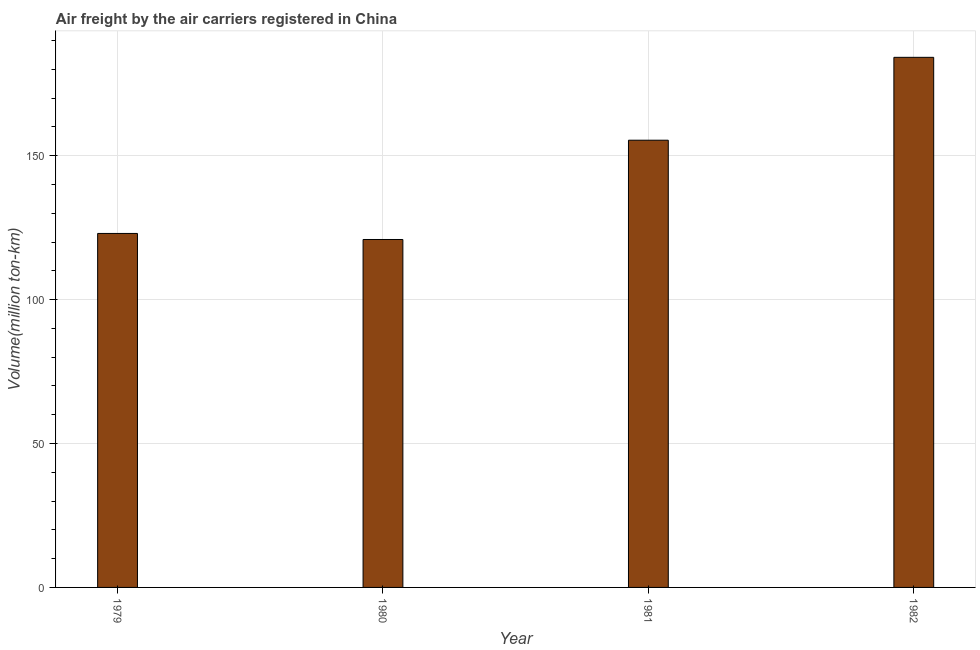Does the graph contain any zero values?
Offer a very short reply. No. Does the graph contain grids?
Make the answer very short. Yes. What is the title of the graph?
Your answer should be very brief. Air freight by the air carriers registered in China. What is the label or title of the Y-axis?
Provide a short and direct response. Volume(million ton-km). What is the air freight in 1980?
Provide a short and direct response. 120.9. Across all years, what is the maximum air freight?
Keep it short and to the point. 184.2. Across all years, what is the minimum air freight?
Offer a terse response. 120.9. What is the sum of the air freight?
Offer a terse response. 583.5. What is the difference between the air freight in 1981 and 1982?
Make the answer very short. -28.8. What is the average air freight per year?
Your answer should be compact. 145.88. What is the median air freight?
Offer a terse response. 139.2. What is the ratio of the air freight in 1980 to that in 1982?
Give a very brief answer. 0.66. Is the difference between the air freight in 1979 and 1982 greater than the difference between any two years?
Your answer should be very brief. No. What is the difference between the highest and the second highest air freight?
Your answer should be compact. 28.8. Is the sum of the air freight in 1980 and 1981 greater than the maximum air freight across all years?
Provide a succinct answer. Yes. What is the difference between the highest and the lowest air freight?
Your answer should be very brief. 63.3. In how many years, is the air freight greater than the average air freight taken over all years?
Your answer should be compact. 2. Are all the bars in the graph horizontal?
Keep it short and to the point. No. What is the difference between two consecutive major ticks on the Y-axis?
Your answer should be compact. 50. Are the values on the major ticks of Y-axis written in scientific E-notation?
Provide a short and direct response. No. What is the Volume(million ton-km) of 1979?
Offer a terse response. 123. What is the Volume(million ton-km) of 1980?
Keep it short and to the point. 120.9. What is the Volume(million ton-km) in 1981?
Keep it short and to the point. 155.4. What is the Volume(million ton-km) of 1982?
Ensure brevity in your answer.  184.2. What is the difference between the Volume(million ton-km) in 1979 and 1981?
Provide a short and direct response. -32.4. What is the difference between the Volume(million ton-km) in 1979 and 1982?
Provide a succinct answer. -61.2. What is the difference between the Volume(million ton-km) in 1980 and 1981?
Make the answer very short. -34.5. What is the difference between the Volume(million ton-km) in 1980 and 1982?
Your answer should be compact. -63.3. What is the difference between the Volume(million ton-km) in 1981 and 1982?
Ensure brevity in your answer.  -28.8. What is the ratio of the Volume(million ton-km) in 1979 to that in 1981?
Provide a short and direct response. 0.79. What is the ratio of the Volume(million ton-km) in 1979 to that in 1982?
Your answer should be very brief. 0.67. What is the ratio of the Volume(million ton-km) in 1980 to that in 1981?
Your answer should be very brief. 0.78. What is the ratio of the Volume(million ton-km) in 1980 to that in 1982?
Your response must be concise. 0.66. What is the ratio of the Volume(million ton-km) in 1981 to that in 1982?
Provide a succinct answer. 0.84. 